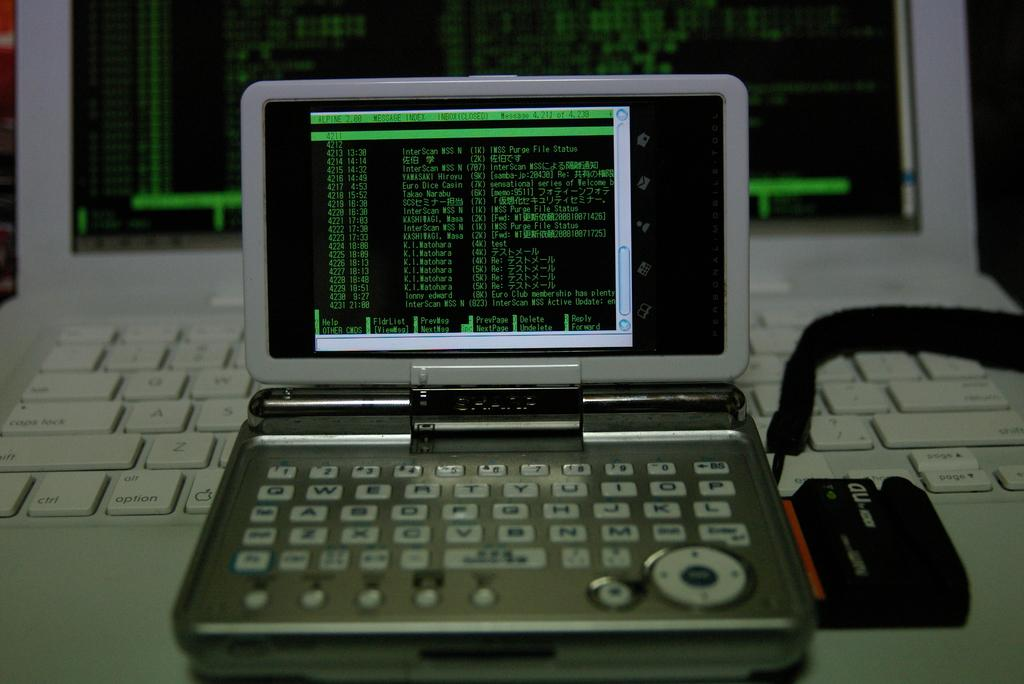<image>
Describe the image concisely. A computer monitor with Message Index written on the screen. 